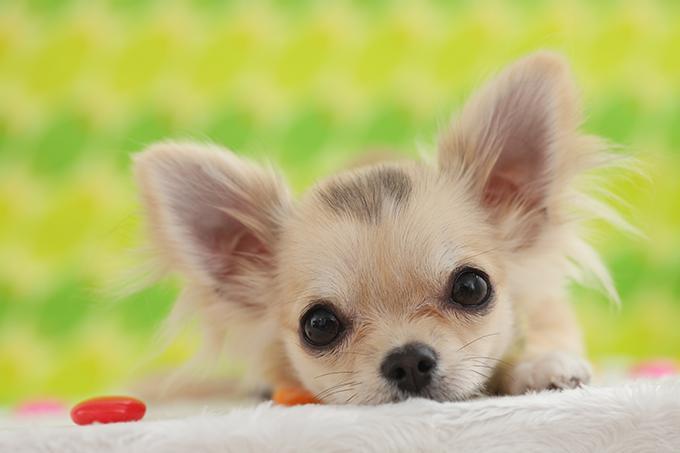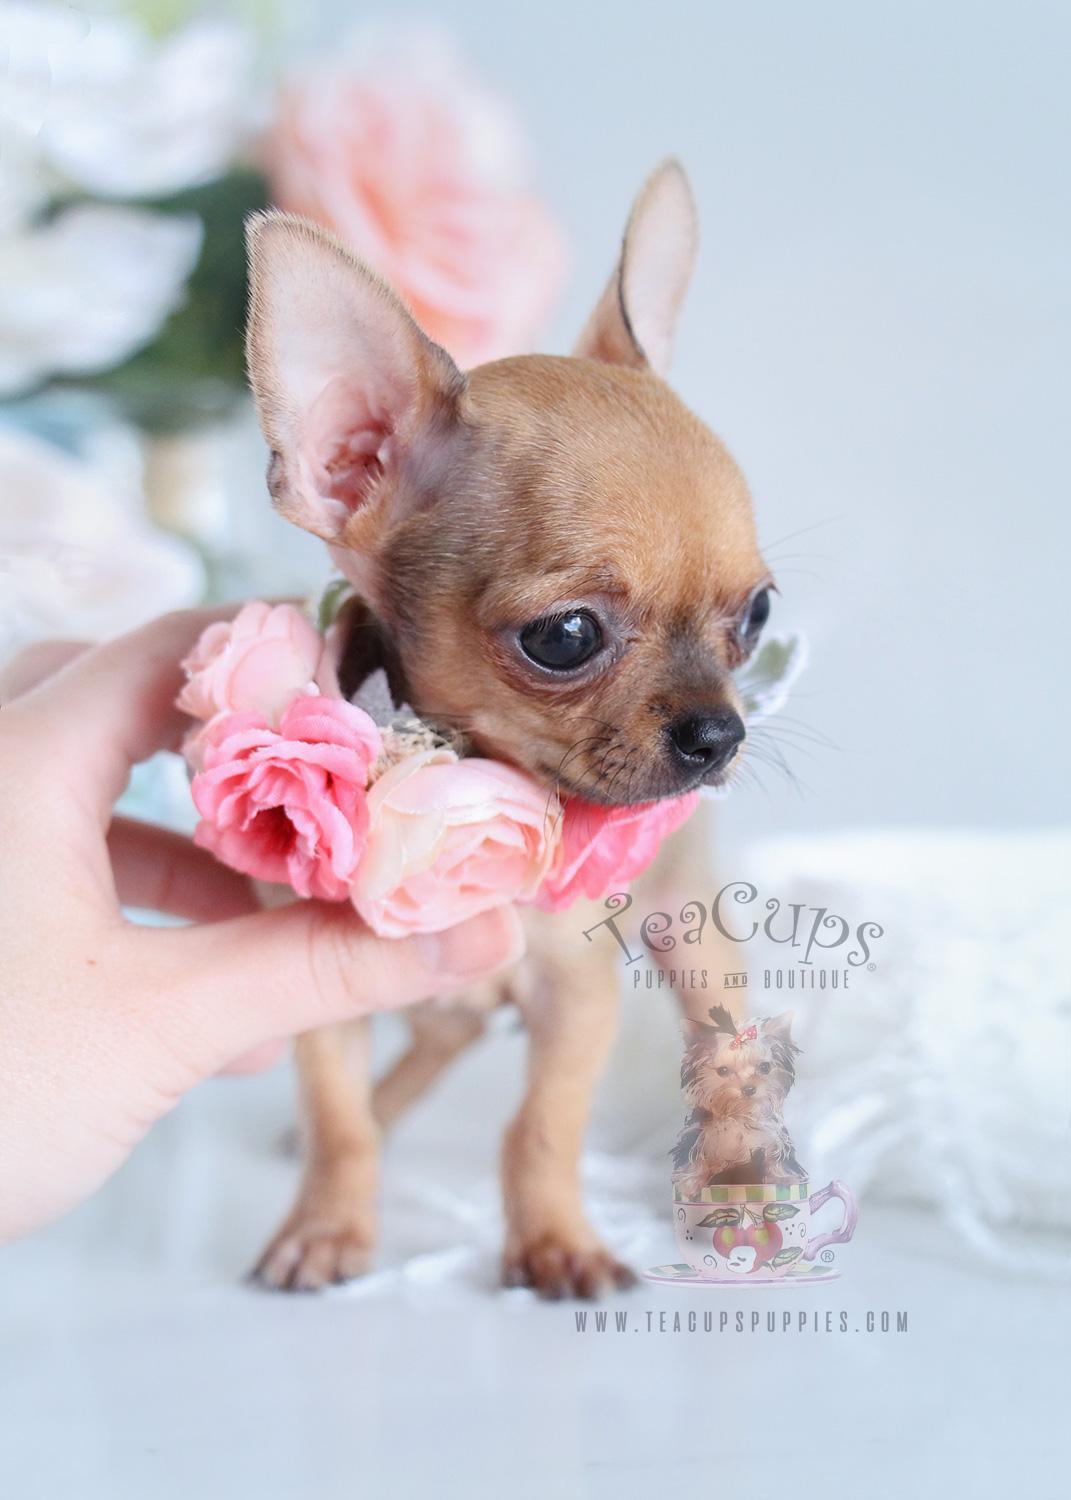The first image is the image on the left, the second image is the image on the right. Given the left and right images, does the statement "In total, the images contain four dogs, but do not contain the same number of dogs in each image." hold true? Answer yes or no. No. The first image is the image on the left, the second image is the image on the right. Examine the images to the left and right. Is the description "A person is holding the dog in one of the images." accurate? Answer yes or no. Yes. 